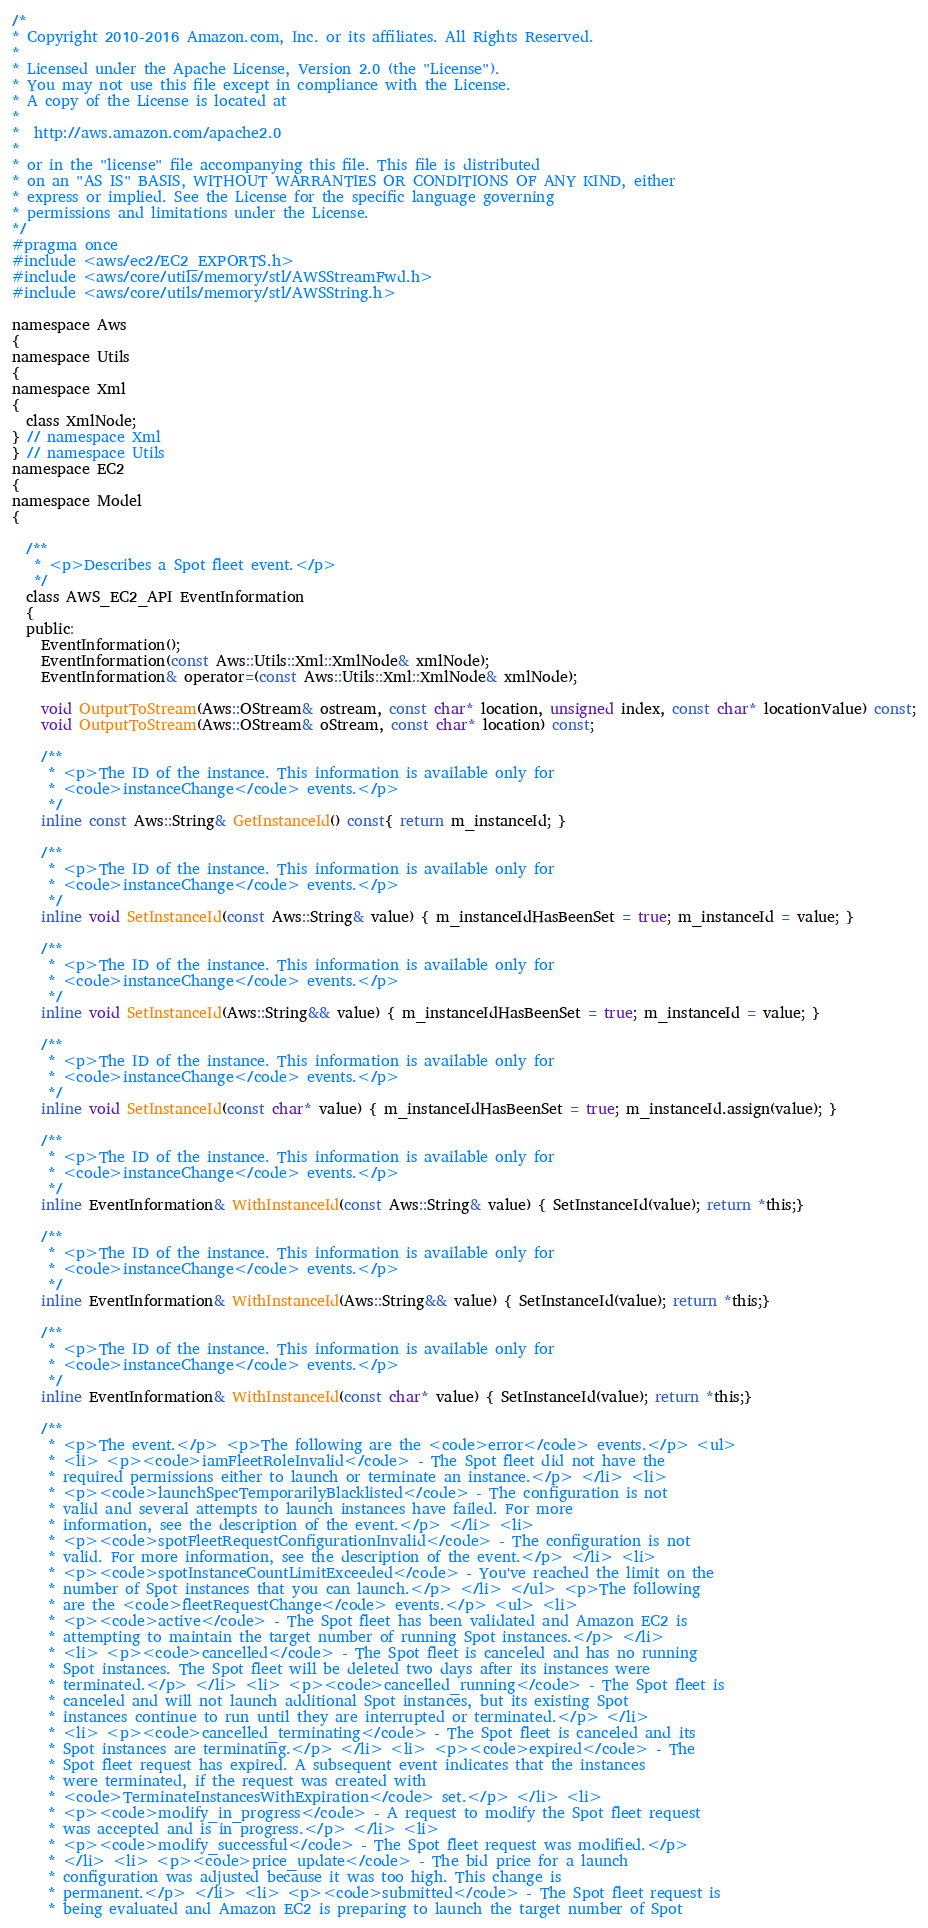<code> <loc_0><loc_0><loc_500><loc_500><_C_>/*
* Copyright 2010-2016 Amazon.com, Inc. or its affiliates. All Rights Reserved.
*
* Licensed under the Apache License, Version 2.0 (the "License").
* You may not use this file except in compliance with the License.
* A copy of the License is located at
*
*  http://aws.amazon.com/apache2.0
*
* or in the "license" file accompanying this file. This file is distributed
* on an "AS IS" BASIS, WITHOUT WARRANTIES OR CONDITIONS OF ANY KIND, either
* express or implied. See the License for the specific language governing
* permissions and limitations under the License.
*/
#pragma once
#include <aws/ec2/EC2_EXPORTS.h>
#include <aws/core/utils/memory/stl/AWSStreamFwd.h>
#include <aws/core/utils/memory/stl/AWSString.h>

namespace Aws
{
namespace Utils
{
namespace Xml
{
  class XmlNode;
} // namespace Xml
} // namespace Utils
namespace EC2
{
namespace Model
{

  /**
   * <p>Describes a Spot fleet event.</p>
   */
  class AWS_EC2_API EventInformation
  {
  public:
    EventInformation();
    EventInformation(const Aws::Utils::Xml::XmlNode& xmlNode);
    EventInformation& operator=(const Aws::Utils::Xml::XmlNode& xmlNode);

    void OutputToStream(Aws::OStream& ostream, const char* location, unsigned index, const char* locationValue) const;
    void OutputToStream(Aws::OStream& oStream, const char* location) const;

    /**
     * <p>The ID of the instance. This information is available only for
     * <code>instanceChange</code> events.</p>
     */
    inline const Aws::String& GetInstanceId() const{ return m_instanceId; }

    /**
     * <p>The ID of the instance. This information is available only for
     * <code>instanceChange</code> events.</p>
     */
    inline void SetInstanceId(const Aws::String& value) { m_instanceIdHasBeenSet = true; m_instanceId = value; }

    /**
     * <p>The ID of the instance. This information is available only for
     * <code>instanceChange</code> events.</p>
     */
    inline void SetInstanceId(Aws::String&& value) { m_instanceIdHasBeenSet = true; m_instanceId = value; }

    /**
     * <p>The ID of the instance. This information is available only for
     * <code>instanceChange</code> events.</p>
     */
    inline void SetInstanceId(const char* value) { m_instanceIdHasBeenSet = true; m_instanceId.assign(value); }

    /**
     * <p>The ID of the instance. This information is available only for
     * <code>instanceChange</code> events.</p>
     */
    inline EventInformation& WithInstanceId(const Aws::String& value) { SetInstanceId(value); return *this;}

    /**
     * <p>The ID of the instance. This information is available only for
     * <code>instanceChange</code> events.</p>
     */
    inline EventInformation& WithInstanceId(Aws::String&& value) { SetInstanceId(value); return *this;}

    /**
     * <p>The ID of the instance. This information is available only for
     * <code>instanceChange</code> events.</p>
     */
    inline EventInformation& WithInstanceId(const char* value) { SetInstanceId(value); return *this;}

    /**
     * <p>The event.</p> <p>The following are the <code>error</code> events.</p> <ul>
     * <li> <p><code>iamFleetRoleInvalid</code> - The Spot fleet did not have the
     * required permissions either to launch or terminate an instance.</p> </li> <li>
     * <p><code>launchSpecTemporarilyBlacklisted</code> - The configuration is not
     * valid and several attempts to launch instances have failed. For more
     * information, see the description of the event.</p> </li> <li>
     * <p><code>spotFleetRequestConfigurationInvalid</code> - The configuration is not
     * valid. For more information, see the description of the event.</p> </li> <li>
     * <p><code>spotInstanceCountLimitExceeded</code> - You've reached the limit on the
     * number of Spot instances that you can launch.</p> </li> </ul> <p>The following
     * are the <code>fleetRequestChange</code> events.</p> <ul> <li>
     * <p><code>active</code> - The Spot fleet has been validated and Amazon EC2 is
     * attempting to maintain the target number of running Spot instances.</p> </li>
     * <li> <p><code>cancelled</code> - The Spot fleet is canceled and has no running
     * Spot instances. The Spot fleet will be deleted two days after its instances were
     * terminated.</p> </li> <li> <p><code>cancelled_running</code> - The Spot fleet is
     * canceled and will not launch additional Spot instances, but its existing Spot
     * instances continue to run until they are interrupted or terminated.</p> </li>
     * <li> <p><code>cancelled_terminating</code> - The Spot fleet is canceled and its
     * Spot instances are terminating.</p> </li> <li> <p><code>expired</code> - The
     * Spot fleet request has expired. A subsequent event indicates that the instances
     * were terminated, if the request was created with
     * <code>TerminateInstancesWithExpiration</code> set.</p> </li> <li>
     * <p><code>modify_in_progress</code> - A request to modify the Spot fleet request
     * was accepted and is in progress.</p> </li> <li>
     * <p><code>modify_successful</code> - The Spot fleet request was modified.</p>
     * </li> <li> <p><code>price_update</code> - The bid price for a launch
     * configuration was adjusted because it was too high. This change is
     * permanent.</p> </li> <li> <p><code>submitted</code> - The Spot fleet request is
     * being evaluated and Amazon EC2 is preparing to launch the target number of Spot</code> 